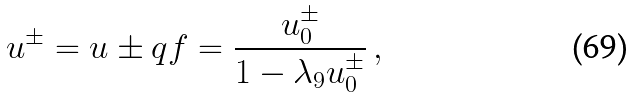<formula> <loc_0><loc_0><loc_500><loc_500>u ^ { \pm } = u \pm q f = \frac { u ^ { \pm } _ { 0 } } { 1 - \lambda _ { 9 } u ^ { \pm } _ { 0 } } \, ,</formula> 